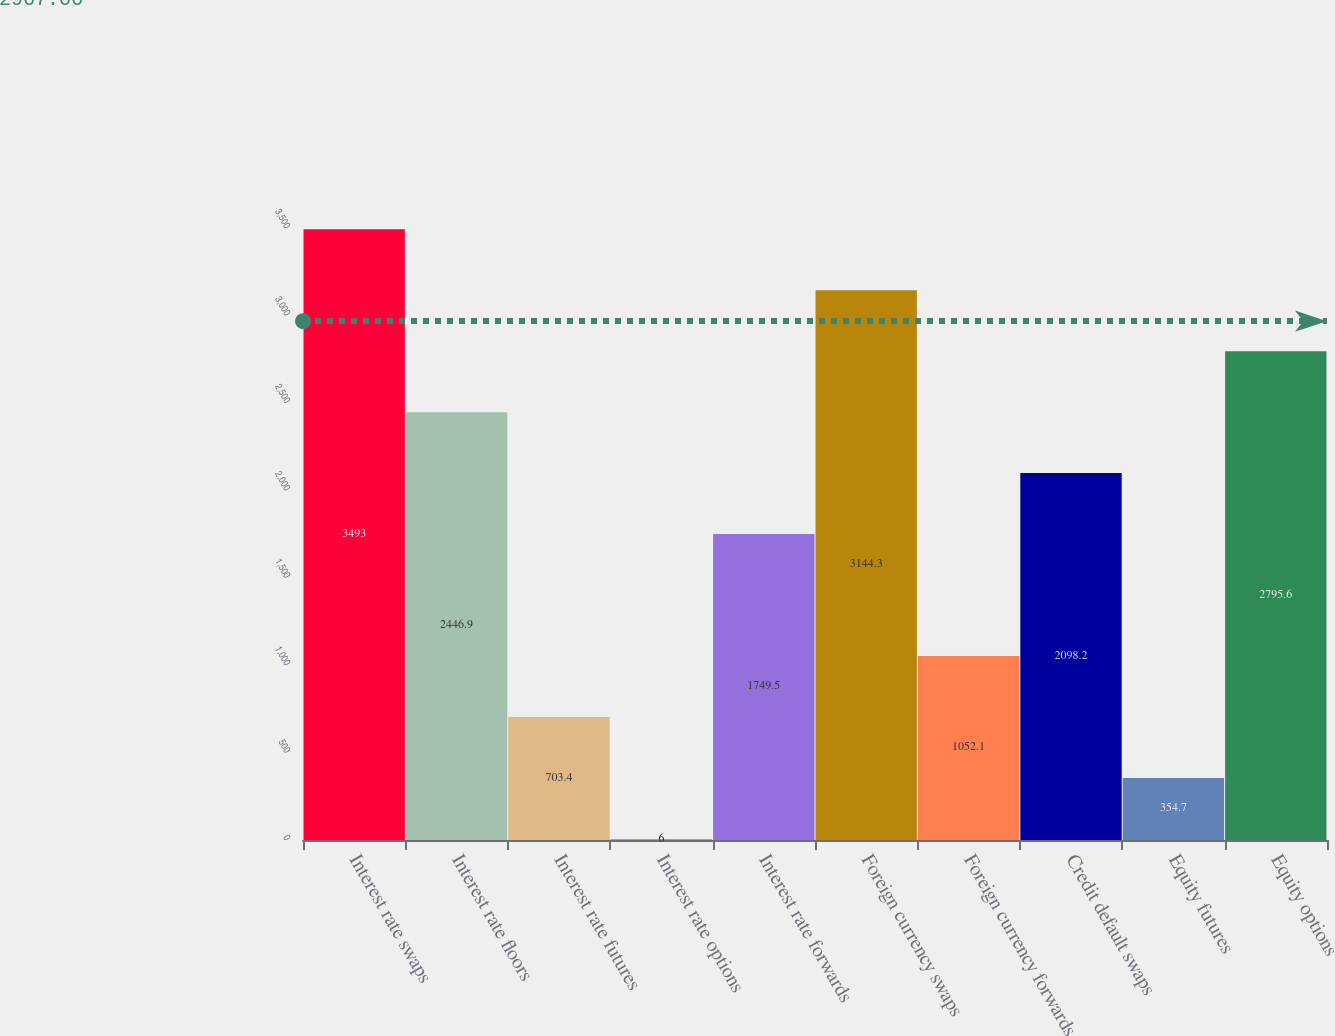Convert chart to OTSL. <chart><loc_0><loc_0><loc_500><loc_500><bar_chart><fcel>Interest rate swaps<fcel>Interest rate floors<fcel>Interest rate futures<fcel>Interest rate options<fcel>Interest rate forwards<fcel>Foreign currency swaps<fcel>Foreign currency forwards<fcel>Credit default swaps<fcel>Equity futures<fcel>Equity options<nl><fcel>3493<fcel>2446.9<fcel>703.4<fcel>6<fcel>1749.5<fcel>3144.3<fcel>1052.1<fcel>2098.2<fcel>354.7<fcel>2795.6<nl></chart> 